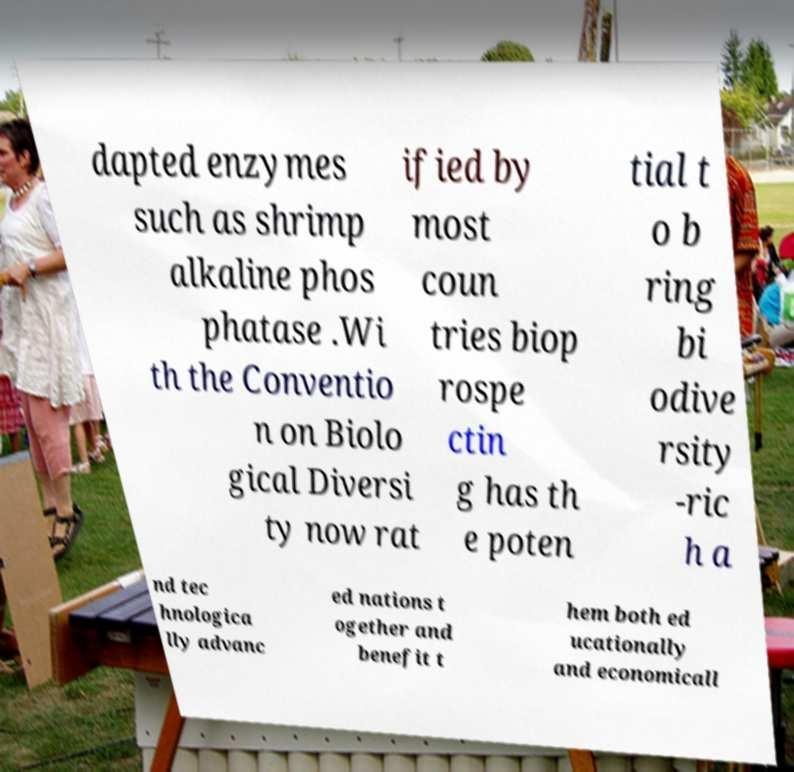Could you extract and type out the text from this image? dapted enzymes such as shrimp alkaline phos phatase .Wi th the Conventio n on Biolo gical Diversi ty now rat ified by most coun tries biop rospe ctin g has th e poten tial t o b ring bi odive rsity -ric h a nd tec hnologica lly advanc ed nations t ogether and benefit t hem both ed ucationally and economicall 